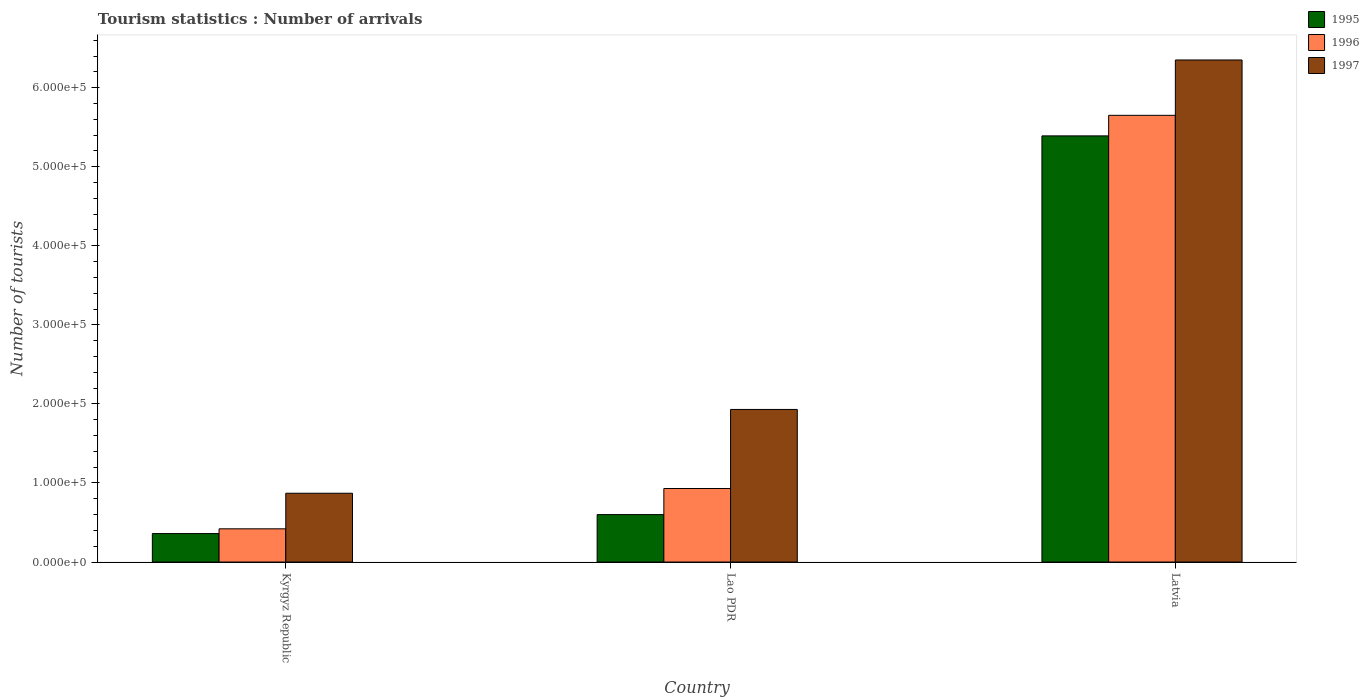How many different coloured bars are there?
Offer a terse response. 3. Are the number of bars on each tick of the X-axis equal?
Ensure brevity in your answer.  Yes. How many bars are there on the 3rd tick from the left?
Your response must be concise. 3. How many bars are there on the 2nd tick from the right?
Give a very brief answer. 3. What is the label of the 2nd group of bars from the left?
Your answer should be very brief. Lao PDR. What is the number of tourist arrivals in 1995 in Kyrgyz Republic?
Offer a terse response. 3.60e+04. Across all countries, what is the maximum number of tourist arrivals in 1996?
Your answer should be very brief. 5.65e+05. Across all countries, what is the minimum number of tourist arrivals in 1995?
Give a very brief answer. 3.60e+04. In which country was the number of tourist arrivals in 1995 maximum?
Keep it short and to the point. Latvia. In which country was the number of tourist arrivals in 1997 minimum?
Your answer should be very brief. Kyrgyz Republic. What is the total number of tourist arrivals in 1996 in the graph?
Offer a terse response. 7.00e+05. What is the difference between the number of tourist arrivals in 1997 in Kyrgyz Republic and that in Lao PDR?
Offer a terse response. -1.06e+05. What is the difference between the number of tourist arrivals in 1996 in Lao PDR and the number of tourist arrivals in 1995 in Kyrgyz Republic?
Offer a very short reply. 5.70e+04. What is the average number of tourist arrivals in 1996 per country?
Your answer should be compact. 2.33e+05. What is the ratio of the number of tourist arrivals in 1997 in Kyrgyz Republic to that in Lao PDR?
Ensure brevity in your answer.  0.45. Is the number of tourist arrivals in 1996 in Lao PDR less than that in Latvia?
Your answer should be compact. Yes. What is the difference between the highest and the second highest number of tourist arrivals in 1996?
Keep it short and to the point. 5.23e+05. What is the difference between the highest and the lowest number of tourist arrivals in 1997?
Offer a terse response. 5.48e+05. Is the sum of the number of tourist arrivals in 1996 in Kyrgyz Republic and Lao PDR greater than the maximum number of tourist arrivals in 1995 across all countries?
Offer a terse response. No. What does the 1st bar from the left in Latvia represents?
Offer a terse response. 1995. Is it the case that in every country, the sum of the number of tourist arrivals in 1995 and number of tourist arrivals in 1997 is greater than the number of tourist arrivals in 1996?
Your answer should be compact. Yes. Are all the bars in the graph horizontal?
Your answer should be compact. No. How many countries are there in the graph?
Make the answer very short. 3. What is the difference between two consecutive major ticks on the Y-axis?
Offer a very short reply. 1.00e+05. Does the graph contain any zero values?
Make the answer very short. No. How are the legend labels stacked?
Make the answer very short. Vertical. What is the title of the graph?
Keep it short and to the point. Tourism statistics : Number of arrivals. Does "1997" appear as one of the legend labels in the graph?
Offer a very short reply. Yes. What is the label or title of the Y-axis?
Give a very brief answer. Number of tourists. What is the Number of tourists of 1995 in Kyrgyz Republic?
Your answer should be very brief. 3.60e+04. What is the Number of tourists of 1996 in Kyrgyz Republic?
Give a very brief answer. 4.20e+04. What is the Number of tourists in 1997 in Kyrgyz Republic?
Give a very brief answer. 8.70e+04. What is the Number of tourists of 1995 in Lao PDR?
Offer a very short reply. 6.00e+04. What is the Number of tourists of 1996 in Lao PDR?
Provide a short and direct response. 9.30e+04. What is the Number of tourists in 1997 in Lao PDR?
Provide a short and direct response. 1.93e+05. What is the Number of tourists of 1995 in Latvia?
Provide a succinct answer. 5.39e+05. What is the Number of tourists of 1996 in Latvia?
Provide a short and direct response. 5.65e+05. What is the Number of tourists of 1997 in Latvia?
Offer a terse response. 6.35e+05. Across all countries, what is the maximum Number of tourists in 1995?
Provide a succinct answer. 5.39e+05. Across all countries, what is the maximum Number of tourists in 1996?
Provide a succinct answer. 5.65e+05. Across all countries, what is the maximum Number of tourists in 1997?
Give a very brief answer. 6.35e+05. Across all countries, what is the minimum Number of tourists of 1995?
Offer a terse response. 3.60e+04. Across all countries, what is the minimum Number of tourists of 1996?
Your answer should be very brief. 4.20e+04. Across all countries, what is the minimum Number of tourists in 1997?
Offer a terse response. 8.70e+04. What is the total Number of tourists of 1995 in the graph?
Ensure brevity in your answer.  6.35e+05. What is the total Number of tourists in 1996 in the graph?
Give a very brief answer. 7.00e+05. What is the total Number of tourists in 1997 in the graph?
Provide a short and direct response. 9.15e+05. What is the difference between the Number of tourists in 1995 in Kyrgyz Republic and that in Lao PDR?
Your answer should be compact. -2.40e+04. What is the difference between the Number of tourists of 1996 in Kyrgyz Republic and that in Lao PDR?
Your answer should be compact. -5.10e+04. What is the difference between the Number of tourists of 1997 in Kyrgyz Republic and that in Lao PDR?
Offer a terse response. -1.06e+05. What is the difference between the Number of tourists in 1995 in Kyrgyz Republic and that in Latvia?
Your answer should be compact. -5.03e+05. What is the difference between the Number of tourists in 1996 in Kyrgyz Republic and that in Latvia?
Make the answer very short. -5.23e+05. What is the difference between the Number of tourists in 1997 in Kyrgyz Republic and that in Latvia?
Offer a very short reply. -5.48e+05. What is the difference between the Number of tourists in 1995 in Lao PDR and that in Latvia?
Provide a succinct answer. -4.79e+05. What is the difference between the Number of tourists of 1996 in Lao PDR and that in Latvia?
Your answer should be very brief. -4.72e+05. What is the difference between the Number of tourists in 1997 in Lao PDR and that in Latvia?
Provide a succinct answer. -4.42e+05. What is the difference between the Number of tourists in 1995 in Kyrgyz Republic and the Number of tourists in 1996 in Lao PDR?
Give a very brief answer. -5.70e+04. What is the difference between the Number of tourists in 1995 in Kyrgyz Republic and the Number of tourists in 1997 in Lao PDR?
Ensure brevity in your answer.  -1.57e+05. What is the difference between the Number of tourists of 1996 in Kyrgyz Republic and the Number of tourists of 1997 in Lao PDR?
Your answer should be very brief. -1.51e+05. What is the difference between the Number of tourists of 1995 in Kyrgyz Republic and the Number of tourists of 1996 in Latvia?
Provide a succinct answer. -5.29e+05. What is the difference between the Number of tourists in 1995 in Kyrgyz Republic and the Number of tourists in 1997 in Latvia?
Give a very brief answer. -5.99e+05. What is the difference between the Number of tourists of 1996 in Kyrgyz Republic and the Number of tourists of 1997 in Latvia?
Make the answer very short. -5.93e+05. What is the difference between the Number of tourists of 1995 in Lao PDR and the Number of tourists of 1996 in Latvia?
Your answer should be compact. -5.05e+05. What is the difference between the Number of tourists of 1995 in Lao PDR and the Number of tourists of 1997 in Latvia?
Your response must be concise. -5.75e+05. What is the difference between the Number of tourists in 1996 in Lao PDR and the Number of tourists in 1997 in Latvia?
Give a very brief answer. -5.42e+05. What is the average Number of tourists in 1995 per country?
Your answer should be very brief. 2.12e+05. What is the average Number of tourists of 1996 per country?
Your response must be concise. 2.33e+05. What is the average Number of tourists in 1997 per country?
Give a very brief answer. 3.05e+05. What is the difference between the Number of tourists of 1995 and Number of tourists of 1996 in Kyrgyz Republic?
Your response must be concise. -6000. What is the difference between the Number of tourists in 1995 and Number of tourists in 1997 in Kyrgyz Republic?
Your answer should be compact. -5.10e+04. What is the difference between the Number of tourists of 1996 and Number of tourists of 1997 in Kyrgyz Republic?
Provide a short and direct response. -4.50e+04. What is the difference between the Number of tourists of 1995 and Number of tourists of 1996 in Lao PDR?
Keep it short and to the point. -3.30e+04. What is the difference between the Number of tourists of 1995 and Number of tourists of 1997 in Lao PDR?
Offer a terse response. -1.33e+05. What is the difference between the Number of tourists of 1996 and Number of tourists of 1997 in Lao PDR?
Give a very brief answer. -1.00e+05. What is the difference between the Number of tourists in 1995 and Number of tourists in 1996 in Latvia?
Your response must be concise. -2.60e+04. What is the difference between the Number of tourists of 1995 and Number of tourists of 1997 in Latvia?
Your answer should be very brief. -9.60e+04. What is the ratio of the Number of tourists in 1996 in Kyrgyz Republic to that in Lao PDR?
Give a very brief answer. 0.45. What is the ratio of the Number of tourists in 1997 in Kyrgyz Republic to that in Lao PDR?
Your answer should be compact. 0.45. What is the ratio of the Number of tourists of 1995 in Kyrgyz Republic to that in Latvia?
Give a very brief answer. 0.07. What is the ratio of the Number of tourists in 1996 in Kyrgyz Republic to that in Latvia?
Your response must be concise. 0.07. What is the ratio of the Number of tourists of 1997 in Kyrgyz Republic to that in Latvia?
Make the answer very short. 0.14. What is the ratio of the Number of tourists of 1995 in Lao PDR to that in Latvia?
Make the answer very short. 0.11. What is the ratio of the Number of tourists of 1996 in Lao PDR to that in Latvia?
Make the answer very short. 0.16. What is the ratio of the Number of tourists of 1997 in Lao PDR to that in Latvia?
Give a very brief answer. 0.3. What is the difference between the highest and the second highest Number of tourists of 1995?
Offer a very short reply. 4.79e+05. What is the difference between the highest and the second highest Number of tourists in 1996?
Provide a succinct answer. 4.72e+05. What is the difference between the highest and the second highest Number of tourists in 1997?
Keep it short and to the point. 4.42e+05. What is the difference between the highest and the lowest Number of tourists in 1995?
Ensure brevity in your answer.  5.03e+05. What is the difference between the highest and the lowest Number of tourists of 1996?
Offer a terse response. 5.23e+05. What is the difference between the highest and the lowest Number of tourists in 1997?
Ensure brevity in your answer.  5.48e+05. 